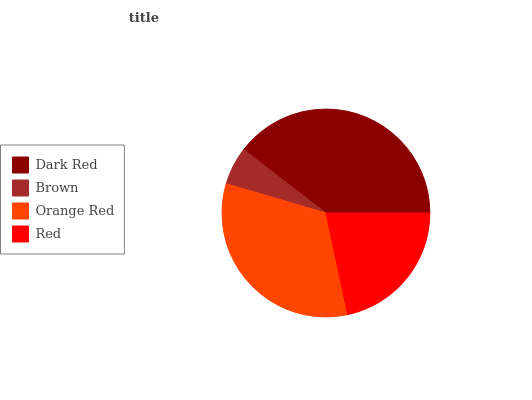Is Brown the minimum?
Answer yes or no. Yes. Is Dark Red the maximum?
Answer yes or no. Yes. Is Orange Red the minimum?
Answer yes or no. No. Is Orange Red the maximum?
Answer yes or no. No. Is Orange Red greater than Brown?
Answer yes or no. Yes. Is Brown less than Orange Red?
Answer yes or no. Yes. Is Brown greater than Orange Red?
Answer yes or no. No. Is Orange Red less than Brown?
Answer yes or no. No. Is Orange Red the high median?
Answer yes or no. Yes. Is Red the low median?
Answer yes or no. Yes. Is Red the high median?
Answer yes or no. No. Is Dark Red the low median?
Answer yes or no. No. 